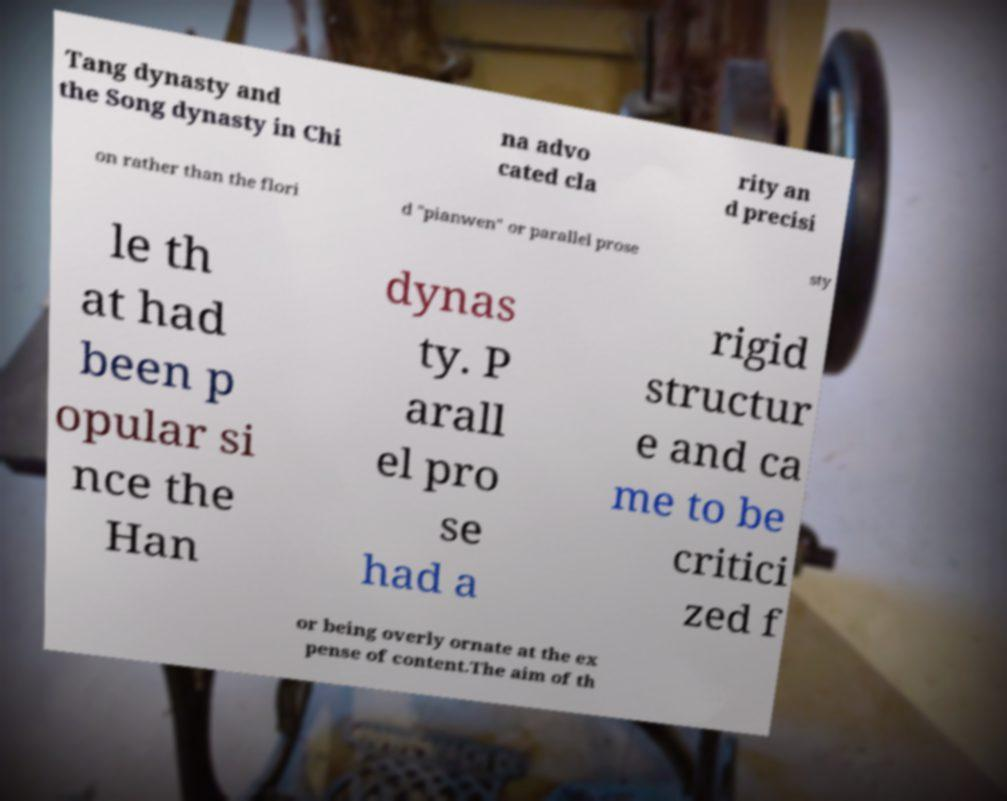What messages or text are displayed in this image? I need them in a readable, typed format. Tang dynasty and the Song dynasty in Chi na advo cated cla rity an d precisi on rather than the flori d "pianwen" or parallel prose sty le th at had been p opular si nce the Han dynas ty. P arall el pro se had a rigid structur e and ca me to be critici zed f or being overly ornate at the ex pense of content.The aim of th 